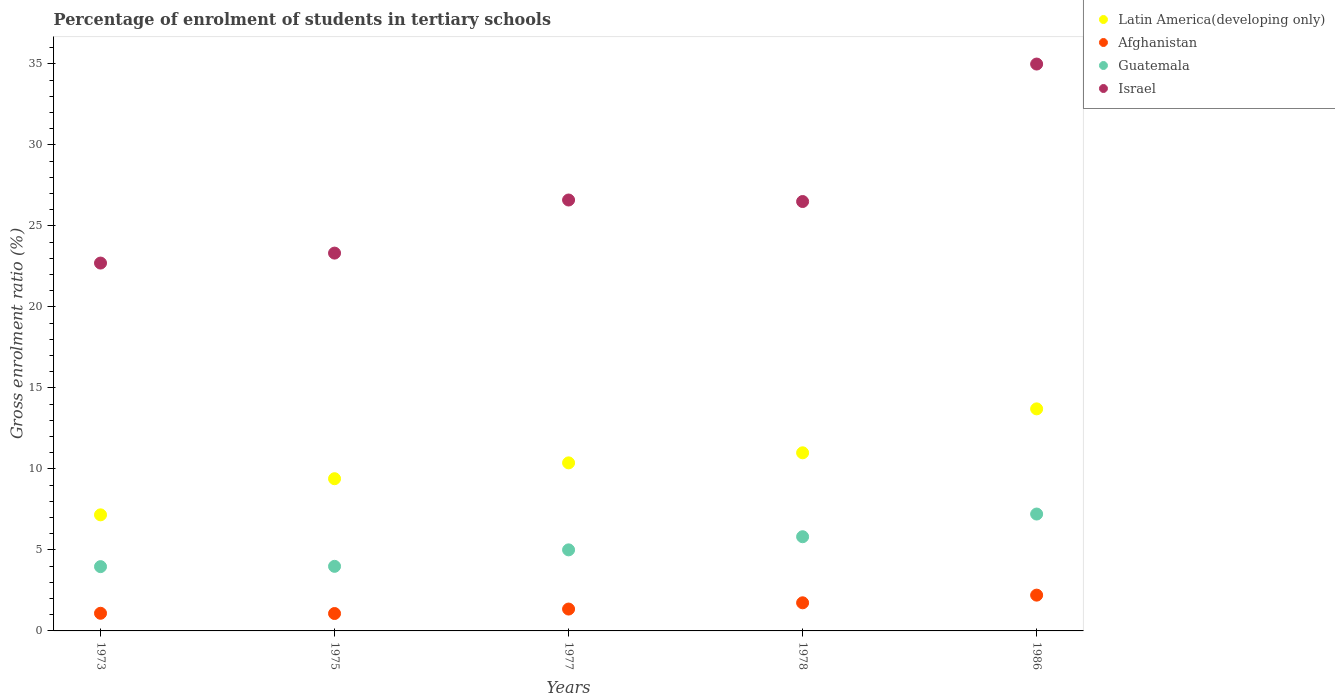Is the number of dotlines equal to the number of legend labels?
Your answer should be very brief. Yes. What is the percentage of students enrolled in tertiary schools in Israel in 1973?
Provide a succinct answer. 22.71. Across all years, what is the maximum percentage of students enrolled in tertiary schools in Guatemala?
Your answer should be compact. 7.21. Across all years, what is the minimum percentage of students enrolled in tertiary schools in Israel?
Your response must be concise. 22.71. In which year was the percentage of students enrolled in tertiary schools in Afghanistan minimum?
Your answer should be compact. 1975. What is the total percentage of students enrolled in tertiary schools in Latin America(developing only) in the graph?
Offer a very short reply. 51.63. What is the difference between the percentage of students enrolled in tertiary schools in Afghanistan in 1977 and that in 1986?
Your answer should be very brief. -0.86. What is the difference between the percentage of students enrolled in tertiary schools in Afghanistan in 1973 and the percentage of students enrolled in tertiary schools in Guatemala in 1977?
Your response must be concise. -3.91. What is the average percentage of students enrolled in tertiary schools in Latin America(developing only) per year?
Provide a short and direct response. 10.33. In the year 1975, what is the difference between the percentage of students enrolled in tertiary schools in Israel and percentage of students enrolled in tertiary schools in Afghanistan?
Offer a terse response. 22.25. In how many years, is the percentage of students enrolled in tertiary schools in Latin America(developing only) greater than 18 %?
Your answer should be very brief. 0. What is the ratio of the percentage of students enrolled in tertiary schools in Guatemala in 1975 to that in 1978?
Offer a very short reply. 0.69. What is the difference between the highest and the second highest percentage of students enrolled in tertiary schools in Latin America(developing only)?
Offer a terse response. 2.71. What is the difference between the highest and the lowest percentage of students enrolled in tertiary schools in Israel?
Offer a very short reply. 12.28. In how many years, is the percentage of students enrolled in tertiary schools in Afghanistan greater than the average percentage of students enrolled in tertiary schools in Afghanistan taken over all years?
Make the answer very short. 2. Is the sum of the percentage of students enrolled in tertiary schools in Guatemala in 1977 and 1986 greater than the maximum percentage of students enrolled in tertiary schools in Afghanistan across all years?
Give a very brief answer. Yes. Is it the case that in every year, the sum of the percentage of students enrolled in tertiary schools in Latin America(developing only) and percentage of students enrolled in tertiary schools in Israel  is greater than the sum of percentage of students enrolled in tertiary schools in Afghanistan and percentage of students enrolled in tertiary schools in Guatemala?
Provide a succinct answer. Yes. Is it the case that in every year, the sum of the percentage of students enrolled in tertiary schools in Latin America(developing only) and percentage of students enrolled in tertiary schools in Guatemala  is greater than the percentage of students enrolled in tertiary schools in Israel?
Offer a very short reply. No. Does the percentage of students enrolled in tertiary schools in Guatemala monotonically increase over the years?
Your answer should be very brief. Yes. Is the percentage of students enrolled in tertiary schools in Latin America(developing only) strictly greater than the percentage of students enrolled in tertiary schools in Guatemala over the years?
Your response must be concise. Yes. Is the percentage of students enrolled in tertiary schools in Afghanistan strictly less than the percentage of students enrolled in tertiary schools in Guatemala over the years?
Ensure brevity in your answer.  Yes. How many years are there in the graph?
Your answer should be very brief. 5. Are the values on the major ticks of Y-axis written in scientific E-notation?
Your answer should be very brief. No. Does the graph contain grids?
Your answer should be very brief. No. Where does the legend appear in the graph?
Offer a terse response. Top right. What is the title of the graph?
Your response must be concise. Percentage of enrolment of students in tertiary schools. What is the Gross enrolment ratio (%) of Latin America(developing only) in 1973?
Offer a terse response. 7.16. What is the Gross enrolment ratio (%) in Afghanistan in 1973?
Your answer should be compact. 1.09. What is the Gross enrolment ratio (%) in Guatemala in 1973?
Keep it short and to the point. 3.97. What is the Gross enrolment ratio (%) in Israel in 1973?
Keep it short and to the point. 22.71. What is the Gross enrolment ratio (%) of Latin America(developing only) in 1975?
Give a very brief answer. 9.4. What is the Gross enrolment ratio (%) of Afghanistan in 1975?
Ensure brevity in your answer.  1.07. What is the Gross enrolment ratio (%) in Guatemala in 1975?
Provide a short and direct response. 3.99. What is the Gross enrolment ratio (%) in Israel in 1975?
Your answer should be compact. 23.32. What is the Gross enrolment ratio (%) of Latin America(developing only) in 1977?
Provide a succinct answer. 10.37. What is the Gross enrolment ratio (%) in Afghanistan in 1977?
Give a very brief answer. 1.35. What is the Gross enrolment ratio (%) in Guatemala in 1977?
Offer a terse response. 5. What is the Gross enrolment ratio (%) of Israel in 1977?
Provide a succinct answer. 26.6. What is the Gross enrolment ratio (%) of Latin America(developing only) in 1978?
Your response must be concise. 10.99. What is the Gross enrolment ratio (%) of Afghanistan in 1978?
Keep it short and to the point. 1.74. What is the Gross enrolment ratio (%) of Guatemala in 1978?
Your answer should be compact. 5.81. What is the Gross enrolment ratio (%) of Israel in 1978?
Your answer should be compact. 26.5. What is the Gross enrolment ratio (%) in Latin America(developing only) in 1986?
Ensure brevity in your answer.  13.71. What is the Gross enrolment ratio (%) of Afghanistan in 1986?
Your answer should be compact. 2.21. What is the Gross enrolment ratio (%) in Guatemala in 1986?
Make the answer very short. 7.21. What is the Gross enrolment ratio (%) in Israel in 1986?
Keep it short and to the point. 34.99. Across all years, what is the maximum Gross enrolment ratio (%) of Latin America(developing only)?
Offer a terse response. 13.71. Across all years, what is the maximum Gross enrolment ratio (%) in Afghanistan?
Provide a succinct answer. 2.21. Across all years, what is the maximum Gross enrolment ratio (%) of Guatemala?
Provide a succinct answer. 7.21. Across all years, what is the maximum Gross enrolment ratio (%) of Israel?
Keep it short and to the point. 34.99. Across all years, what is the minimum Gross enrolment ratio (%) of Latin America(developing only)?
Provide a succinct answer. 7.16. Across all years, what is the minimum Gross enrolment ratio (%) in Afghanistan?
Your response must be concise. 1.07. Across all years, what is the minimum Gross enrolment ratio (%) of Guatemala?
Your response must be concise. 3.97. Across all years, what is the minimum Gross enrolment ratio (%) in Israel?
Keep it short and to the point. 22.71. What is the total Gross enrolment ratio (%) in Latin America(developing only) in the graph?
Provide a succinct answer. 51.63. What is the total Gross enrolment ratio (%) of Afghanistan in the graph?
Offer a very short reply. 7.46. What is the total Gross enrolment ratio (%) in Guatemala in the graph?
Give a very brief answer. 25.99. What is the total Gross enrolment ratio (%) in Israel in the graph?
Offer a very short reply. 134.12. What is the difference between the Gross enrolment ratio (%) of Latin America(developing only) in 1973 and that in 1975?
Your answer should be very brief. -2.23. What is the difference between the Gross enrolment ratio (%) of Afghanistan in 1973 and that in 1975?
Make the answer very short. 0.02. What is the difference between the Gross enrolment ratio (%) in Guatemala in 1973 and that in 1975?
Make the answer very short. -0.02. What is the difference between the Gross enrolment ratio (%) of Israel in 1973 and that in 1975?
Offer a terse response. -0.61. What is the difference between the Gross enrolment ratio (%) of Latin America(developing only) in 1973 and that in 1977?
Make the answer very short. -3.21. What is the difference between the Gross enrolment ratio (%) of Afghanistan in 1973 and that in 1977?
Offer a very short reply. -0.26. What is the difference between the Gross enrolment ratio (%) of Guatemala in 1973 and that in 1977?
Give a very brief answer. -1.04. What is the difference between the Gross enrolment ratio (%) in Israel in 1973 and that in 1977?
Ensure brevity in your answer.  -3.89. What is the difference between the Gross enrolment ratio (%) of Latin America(developing only) in 1973 and that in 1978?
Give a very brief answer. -3.83. What is the difference between the Gross enrolment ratio (%) in Afghanistan in 1973 and that in 1978?
Provide a short and direct response. -0.65. What is the difference between the Gross enrolment ratio (%) in Guatemala in 1973 and that in 1978?
Your answer should be very brief. -1.85. What is the difference between the Gross enrolment ratio (%) of Israel in 1973 and that in 1978?
Your answer should be compact. -3.8. What is the difference between the Gross enrolment ratio (%) in Latin America(developing only) in 1973 and that in 1986?
Keep it short and to the point. -6.54. What is the difference between the Gross enrolment ratio (%) of Afghanistan in 1973 and that in 1986?
Your response must be concise. -1.12. What is the difference between the Gross enrolment ratio (%) of Guatemala in 1973 and that in 1986?
Ensure brevity in your answer.  -3.25. What is the difference between the Gross enrolment ratio (%) of Israel in 1973 and that in 1986?
Your answer should be compact. -12.28. What is the difference between the Gross enrolment ratio (%) of Latin America(developing only) in 1975 and that in 1977?
Your answer should be very brief. -0.98. What is the difference between the Gross enrolment ratio (%) of Afghanistan in 1975 and that in 1977?
Your answer should be compact. -0.28. What is the difference between the Gross enrolment ratio (%) of Guatemala in 1975 and that in 1977?
Provide a short and direct response. -1.02. What is the difference between the Gross enrolment ratio (%) of Israel in 1975 and that in 1977?
Ensure brevity in your answer.  -3.28. What is the difference between the Gross enrolment ratio (%) of Latin America(developing only) in 1975 and that in 1978?
Make the answer very short. -1.6. What is the difference between the Gross enrolment ratio (%) of Afghanistan in 1975 and that in 1978?
Offer a terse response. -0.66. What is the difference between the Gross enrolment ratio (%) in Guatemala in 1975 and that in 1978?
Give a very brief answer. -1.83. What is the difference between the Gross enrolment ratio (%) in Israel in 1975 and that in 1978?
Your response must be concise. -3.18. What is the difference between the Gross enrolment ratio (%) in Latin America(developing only) in 1975 and that in 1986?
Offer a terse response. -4.31. What is the difference between the Gross enrolment ratio (%) of Afghanistan in 1975 and that in 1986?
Offer a very short reply. -1.13. What is the difference between the Gross enrolment ratio (%) in Guatemala in 1975 and that in 1986?
Your answer should be compact. -3.23. What is the difference between the Gross enrolment ratio (%) in Israel in 1975 and that in 1986?
Your answer should be very brief. -11.67. What is the difference between the Gross enrolment ratio (%) of Latin America(developing only) in 1977 and that in 1978?
Provide a succinct answer. -0.62. What is the difference between the Gross enrolment ratio (%) of Afghanistan in 1977 and that in 1978?
Your answer should be very brief. -0.39. What is the difference between the Gross enrolment ratio (%) of Guatemala in 1977 and that in 1978?
Provide a succinct answer. -0.81. What is the difference between the Gross enrolment ratio (%) of Israel in 1977 and that in 1978?
Your response must be concise. 0.09. What is the difference between the Gross enrolment ratio (%) of Latin America(developing only) in 1977 and that in 1986?
Your response must be concise. -3.33. What is the difference between the Gross enrolment ratio (%) of Afghanistan in 1977 and that in 1986?
Ensure brevity in your answer.  -0.86. What is the difference between the Gross enrolment ratio (%) of Guatemala in 1977 and that in 1986?
Your response must be concise. -2.21. What is the difference between the Gross enrolment ratio (%) in Israel in 1977 and that in 1986?
Provide a short and direct response. -8.39. What is the difference between the Gross enrolment ratio (%) in Latin America(developing only) in 1978 and that in 1986?
Give a very brief answer. -2.71. What is the difference between the Gross enrolment ratio (%) in Afghanistan in 1978 and that in 1986?
Provide a succinct answer. -0.47. What is the difference between the Gross enrolment ratio (%) in Guatemala in 1978 and that in 1986?
Make the answer very short. -1.4. What is the difference between the Gross enrolment ratio (%) of Israel in 1978 and that in 1986?
Make the answer very short. -8.49. What is the difference between the Gross enrolment ratio (%) of Latin America(developing only) in 1973 and the Gross enrolment ratio (%) of Afghanistan in 1975?
Provide a succinct answer. 6.09. What is the difference between the Gross enrolment ratio (%) of Latin America(developing only) in 1973 and the Gross enrolment ratio (%) of Guatemala in 1975?
Keep it short and to the point. 3.18. What is the difference between the Gross enrolment ratio (%) in Latin America(developing only) in 1973 and the Gross enrolment ratio (%) in Israel in 1975?
Ensure brevity in your answer.  -16.16. What is the difference between the Gross enrolment ratio (%) in Afghanistan in 1973 and the Gross enrolment ratio (%) in Guatemala in 1975?
Your answer should be very brief. -2.9. What is the difference between the Gross enrolment ratio (%) in Afghanistan in 1973 and the Gross enrolment ratio (%) in Israel in 1975?
Your answer should be compact. -22.23. What is the difference between the Gross enrolment ratio (%) of Guatemala in 1973 and the Gross enrolment ratio (%) of Israel in 1975?
Provide a short and direct response. -19.35. What is the difference between the Gross enrolment ratio (%) of Latin America(developing only) in 1973 and the Gross enrolment ratio (%) of Afghanistan in 1977?
Your answer should be compact. 5.81. What is the difference between the Gross enrolment ratio (%) of Latin America(developing only) in 1973 and the Gross enrolment ratio (%) of Guatemala in 1977?
Offer a very short reply. 2.16. What is the difference between the Gross enrolment ratio (%) in Latin America(developing only) in 1973 and the Gross enrolment ratio (%) in Israel in 1977?
Keep it short and to the point. -19.43. What is the difference between the Gross enrolment ratio (%) in Afghanistan in 1973 and the Gross enrolment ratio (%) in Guatemala in 1977?
Your answer should be compact. -3.91. What is the difference between the Gross enrolment ratio (%) of Afghanistan in 1973 and the Gross enrolment ratio (%) of Israel in 1977?
Offer a very short reply. -25.51. What is the difference between the Gross enrolment ratio (%) in Guatemala in 1973 and the Gross enrolment ratio (%) in Israel in 1977?
Make the answer very short. -22.63. What is the difference between the Gross enrolment ratio (%) of Latin America(developing only) in 1973 and the Gross enrolment ratio (%) of Afghanistan in 1978?
Ensure brevity in your answer.  5.43. What is the difference between the Gross enrolment ratio (%) of Latin America(developing only) in 1973 and the Gross enrolment ratio (%) of Guatemala in 1978?
Provide a short and direct response. 1.35. What is the difference between the Gross enrolment ratio (%) in Latin America(developing only) in 1973 and the Gross enrolment ratio (%) in Israel in 1978?
Your answer should be compact. -19.34. What is the difference between the Gross enrolment ratio (%) in Afghanistan in 1973 and the Gross enrolment ratio (%) in Guatemala in 1978?
Make the answer very short. -4.72. What is the difference between the Gross enrolment ratio (%) in Afghanistan in 1973 and the Gross enrolment ratio (%) in Israel in 1978?
Provide a short and direct response. -25.41. What is the difference between the Gross enrolment ratio (%) in Guatemala in 1973 and the Gross enrolment ratio (%) in Israel in 1978?
Your answer should be very brief. -22.54. What is the difference between the Gross enrolment ratio (%) of Latin America(developing only) in 1973 and the Gross enrolment ratio (%) of Afghanistan in 1986?
Provide a short and direct response. 4.96. What is the difference between the Gross enrolment ratio (%) in Latin America(developing only) in 1973 and the Gross enrolment ratio (%) in Guatemala in 1986?
Make the answer very short. -0.05. What is the difference between the Gross enrolment ratio (%) in Latin America(developing only) in 1973 and the Gross enrolment ratio (%) in Israel in 1986?
Offer a terse response. -27.82. What is the difference between the Gross enrolment ratio (%) of Afghanistan in 1973 and the Gross enrolment ratio (%) of Guatemala in 1986?
Your answer should be very brief. -6.12. What is the difference between the Gross enrolment ratio (%) in Afghanistan in 1973 and the Gross enrolment ratio (%) in Israel in 1986?
Keep it short and to the point. -33.9. What is the difference between the Gross enrolment ratio (%) of Guatemala in 1973 and the Gross enrolment ratio (%) of Israel in 1986?
Ensure brevity in your answer.  -31.02. What is the difference between the Gross enrolment ratio (%) of Latin America(developing only) in 1975 and the Gross enrolment ratio (%) of Afghanistan in 1977?
Your answer should be very brief. 8.05. What is the difference between the Gross enrolment ratio (%) in Latin America(developing only) in 1975 and the Gross enrolment ratio (%) in Guatemala in 1977?
Your answer should be very brief. 4.39. What is the difference between the Gross enrolment ratio (%) in Latin America(developing only) in 1975 and the Gross enrolment ratio (%) in Israel in 1977?
Provide a short and direct response. -17.2. What is the difference between the Gross enrolment ratio (%) of Afghanistan in 1975 and the Gross enrolment ratio (%) of Guatemala in 1977?
Offer a very short reply. -3.93. What is the difference between the Gross enrolment ratio (%) in Afghanistan in 1975 and the Gross enrolment ratio (%) in Israel in 1977?
Your answer should be compact. -25.52. What is the difference between the Gross enrolment ratio (%) in Guatemala in 1975 and the Gross enrolment ratio (%) in Israel in 1977?
Your response must be concise. -22.61. What is the difference between the Gross enrolment ratio (%) of Latin America(developing only) in 1975 and the Gross enrolment ratio (%) of Afghanistan in 1978?
Provide a succinct answer. 7.66. What is the difference between the Gross enrolment ratio (%) in Latin America(developing only) in 1975 and the Gross enrolment ratio (%) in Guatemala in 1978?
Make the answer very short. 3.58. What is the difference between the Gross enrolment ratio (%) in Latin America(developing only) in 1975 and the Gross enrolment ratio (%) in Israel in 1978?
Provide a succinct answer. -17.11. What is the difference between the Gross enrolment ratio (%) in Afghanistan in 1975 and the Gross enrolment ratio (%) in Guatemala in 1978?
Provide a short and direct response. -4.74. What is the difference between the Gross enrolment ratio (%) of Afghanistan in 1975 and the Gross enrolment ratio (%) of Israel in 1978?
Offer a terse response. -25.43. What is the difference between the Gross enrolment ratio (%) in Guatemala in 1975 and the Gross enrolment ratio (%) in Israel in 1978?
Keep it short and to the point. -22.52. What is the difference between the Gross enrolment ratio (%) of Latin America(developing only) in 1975 and the Gross enrolment ratio (%) of Afghanistan in 1986?
Ensure brevity in your answer.  7.19. What is the difference between the Gross enrolment ratio (%) in Latin America(developing only) in 1975 and the Gross enrolment ratio (%) in Guatemala in 1986?
Provide a short and direct response. 2.18. What is the difference between the Gross enrolment ratio (%) of Latin America(developing only) in 1975 and the Gross enrolment ratio (%) of Israel in 1986?
Keep it short and to the point. -25.59. What is the difference between the Gross enrolment ratio (%) of Afghanistan in 1975 and the Gross enrolment ratio (%) of Guatemala in 1986?
Your answer should be compact. -6.14. What is the difference between the Gross enrolment ratio (%) in Afghanistan in 1975 and the Gross enrolment ratio (%) in Israel in 1986?
Your response must be concise. -33.91. What is the difference between the Gross enrolment ratio (%) of Guatemala in 1975 and the Gross enrolment ratio (%) of Israel in 1986?
Offer a terse response. -31. What is the difference between the Gross enrolment ratio (%) of Latin America(developing only) in 1977 and the Gross enrolment ratio (%) of Afghanistan in 1978?
Your response must be concise. 8.64. What is the difference between the Gross enrolment ratio (%) in Latin America(developing only) in 1977 and the Gross enrolment ratio (%) in Guatemala in 1978?
Your answer should be compact. 4.56. What is the difference between the Gross enrolment ratio (%) in Latin America(developing only) in 1977 and the Gross enrolment ratio (%) in Israel in 1978?
Offer a terse response. -16.13. What is the difference between the Gross enrolment ratio (%) in Afghanistan in 1977 and the Gross enrolment ratio (%) in Guatemala in 1978?
Offer a very short reply. -4.46. What is the difference between the Gross enrolment ratio (%) in Afghanistan in 1977 and the Gross enrolment ratio (%) in Israel in 1978?
Your answer should be compact. -25.15. What is the difference between the Gross enrolment ratio (%) of Guatemala in 1977 and the Gross enrolment ratio (%) of Israel in 1978?
Give a very brief answer. -21.5. What is the difference between the Gross enrolment ratio (%) in Latin America(developing only) in 1977 and the Gross enrolment ratio (%) in Afghanistan in 1986?
Provide a short and direct response. 8.16. What is the difference between the Gross enrolment ratio (%) in Latin America(developing only) in 1977 and the Gross enrolment ratio (%) in Guatemala in 1986?
Your answer should be very brief. 3.16. What is the difference between the Gross enrolment ratio (%) of Latin America(developing only) in 1977 and the Gross enrolment ratio (%) of Israel in 1986?
Offer a terse response. -24.62. What is the difference between the Gross enrolment ratio (%) of Afghanistan in 1977 and the Gross enrolment ratio (%) of Guatemala in 1986?
Offer a terse response. -5.86. What is the difference between the Gross enrolment ratio (%) in Afghanistan in 1977 and the Gross enrolment ratio (%) in Israel in 1986?
Offer a very short reply. -33.64. What is the difference between the Gross enrolment ratio (%) of Guatemala in 1977 and the Gross enrolment ratio (%) of Israel in 1986?
Offer a terse response. -29.99. What is the difference between the Gross enrolment ratio (%) of Latin America(developing only) in 1978 and the Gross enrolment ratio (%) of Afghanistan in 1986?
Keep it short and to the point. 8.79. What is the difference between the Gross enrolment ratio (%) in Latin America(developing only) in 1978 and the Gross enrolment ratio (%) in Guatemala in 1986?
Your answer should be very brief. 3.78. What is the difference between the Gross enrolment ratio (%) in Latin America(developing only) in 1978 and the Gross enrolment ratio (%) in Israel in 1986?
Make the answer very short. -24. What is the difference between the Gross enrolment ratio (%) in Afghanistan in 1978 and the Gross enrolment ratio (%) in Guatemala in 1986?
Your answer should be compact. -5.48. What is the difference between the Gross enrolment ratio (%) of Afghanistan in 1978 and the Gross enrolment ratio (%) of Israel in 1986?
Provide a succinct answer. -33.25. What is the difference between the Gross enrolment ratio (%) in Guatemala in 1978 and the Gross enrolment ratio (%) in Israel in 1986?
Ensure brevity in your answer.  -29.18. What is the average Gross enrolment ratio (%) in Latin America(developing only) per year?
Give a very brief answer. 10.33. What is the average Gross enrolment ratio (%) of Afghanistan per year?
Your answer should be very brief. 1.49. What is the average Gross enrolment ratio (%) in Guatemala per year?
Your answer should be compact. 5.2. What is the average Gross enrolment ratio (%) of Israel per year?
Your response must be concise. 26.82. In the year 1973, what is the difference between the Gross enrolment ratio (%) of Latin America(developing only) and Gross enrolment ratio (%) of Afghanistan?
Offer a very short reply. 6.08. In the year 1973, what is the difference between the Gross enrolment ratio (%) of Latin America(developing only) and Gross enrolment ratio (%) of Guatemala?
Keep it short and to the point. 3.2. In the year 1973, what is the difference between the Gross enrolment ratio (%) in Latin America(developing only) and Gross enrolment ratio (%) in Israel?
Ensure brevity in your answer.  -15.54. In the year 1973, what is the difference between the Gross enrolment ratio (%) in Afghanistan and Gross enrolment ratio (%) in Guatemala?
Your answer should be very brief. -2.88. In the year 1973, what is the difference between the Gross enrolment ratio (%) of Afghanistan and Gross enrolment ratio (%) of Israel?
Your response must be concise. -21.62. In the year 1973, what is the difference between the Gross enrolment ratio (%) of Guatemala and Gross enrolment ratio (%) of Israel?
Ensure brevity in your answer.  -18.74. In the year 1975, what is the difference between the Gross enrolment ratio (%) of Latin America(developing only) and Gross enrolment ratio (%) of Afghanistan?
Your response must be concise. 8.32. In the year 1975, what is the difference between the Gross enrolment ratio (%) in Latin America(developing only) and Gross enrolment ratio (%) in Guatemala?
Make the answer very short. 5.41. In the year 1975, what is the difference between the Gross enrolment ratio (%) in Latin America(developing only) and Gross enrolment ratio (%) in Israel?
Your response must be concise. -13.92. In the year 1975, what is the difference between the Gross enrolment ratio (%) in Afghanistan and Gross enrolment ratio (%) in Guatemala?
Give a very brief answer. -2.91. In the year 1975, what is the difference between the Gross enrolment ratio (%) of Afghanistan and Gross enrolment ratio (%) of Israel?
Give a very brief answer. -22.25. In the year 1975, what is the difference between the Gross enrolment ratio (%) in Guatemala and Gross enrolment ratio (%) in Israel?
Offer a very short reply. -19.33. In the year 1977, what is the difference between the Gross enrolment ratio (%) of Latin America(developing only) and Gross enrolment ratio (%) of Afghanistan?
Provide a short and direct response. 9.02. In the year 1977, what is the difference between the Gross enrolment ratio (%) of Latin America(developing only) and Gross enrolment ratio (%) of Guatemala?
Your response must be concise. 5.37. In the year 1977, what is the difference between the Gross enrolment ratio (%) in Latin America(developing only) and Gross enrolment ratio (%) in Israel?
Ensure brevity in your answer.  -16.22. In the year 1977, what is the difference between the Gross enrolment ratio (%) in Afghanistan and Gross enrolment ratio (%) in Guatemala?
Your answer should be very brief. -3.65. In the year 1977, what is the difference between the Gross enrolment ratio (%) of Afghanistan and Gross enrolment ratio (%) of Israel?
Your response must be concise. -25.25. In the year 1977, what is the difference between the Gross enrolment ratio (%) in Guatemala and Gross enrolment ratio (%) in Israel?
Your answer should be compact. -21.59. In the year 1978, what is the difference between the Gross enrolment ratio (%) in Latin America(developing only) and Gross enrolment ratio (%) in Afghanistan?
Offer a very short reply. 9.26. In the year 1978, what is the difference between the Gross enrolment ratio (%) in Latin America(developing only) and Gross enrolment ratio (%) in Guatemala?
Your response must be concise. 5.18. In the year 1978, what is the difference between the Gross enrolment ratio (%) in Latin America(developing only) and Gross enrolment ratio (%) in Israel?
Offer a very short reply. -15.51. In the year 1978, what is the difference between the Gross enrolment ratio (%) of Afghanistan and Gross enrolment ratio (%) of Guatemala?
Provide a succinct answer. -4.08. In the year 1978, what is the difference between the Gross enrolment ratio (%) of Afghanistan and Gross enrolment ratio (%) of Israel?
Offer a terse response. -24.77. In the year 1978, what is the difference between the Gross enrolment ratio (%) of Guatemala and Gross enrolment ratio (%) of Israel?
Provide a succinct answer. -20.69. In the year 1986, what is the difference between the Gross enrolment ratio (%) in Latin America(developing only) and Gross enrolment ratio (%) in Afghanistan?
Provide a short and direct response. 11.5. In the year 1986, what is the difference between the Gross enrolment ratio (%) in Latin America(developing only) and Gross enrolment ratio (%) in Guatemala?
Your answer should be compact. 6.49. In the year 1986, what is the difference between the Gross enrolment ratio (%) of Latin America(developing only) and Gross enrolment ratio (%) of Israel?
Your answer should be compact. -21.28. In the year 1986, what is the difference between the Gross enrolment ratio (%) of Afghanistan and Gross enrolment ratio (%) of Guatemala?
Provide a succinct answer. -5.01. In the year 1986, what is the difference between the Gross enrolment ratio (%) of Afghanistan and Gross enrolment ratio (%) of Israel?
Offer a very short reply. -32.78. In the year 1986, what is the difference between the Gross enrolment ratio (%) in Guatemala and Gross enrolment ratio (%) in Israel?
Your answer should be compact. -27.77. What is the ratio of the Gross enrolment ratio (%) of Latin America(developing only) in 1973 to that in 1975?
Offer a terse response. 0.76. What is the ratio of the Gross enrolment ratio (%) in Afghanistan in 1973 to that in 1975?
Ensure brevity in your answer.  1.01. What is the ratio of the Gross enrolment ratio (%) in Guatemala in 1973 to that in 1975?
Your answer should be very brief. 1. What is the ratio of the Gross enrolment ratio (%) of Israel in 1973 to that in 1975?
Your answer should be very brief. 0.97. What is the ratio of the Gross enrolment ratio (%) in Latin America(developing only) in 1973 to that in 1977?
Keep it short and to the point. 0.69. What is the ratio of the Gross enrolment ratio (%) of Afghanistan in 1973 to that in 1977?
Ensure brevity in your answer.  0.81. What is the ratio of the Gross enrolment ratio (%) in Guatemala in 1973 to that in 1977?
Ensure brevity in your answer.  0.79. What is the ratio of the Gross enrolment ratio (%) of Israel in 1973 to that in 1977?
Make the answer very short. 0.85. What is the ratio of the Gross enrolment ratio (%) of Latin America(developing only) in 1973 to that in 1978?
Give a very brief answer. 0.65. What is the ratio of the Gross enrolment ratio (%) of Afghanistan in 1973 to that in 1978?
Keep it short and to the point. 0.63. What is the ratio of the Gross enrolment ratio (%) of Guatemala in 1973 to that in 1978?
Provide a short and direct response. 0.68. What is the ratio of the Gross enrolment ratio (%) in Israel in 1973 to that in 1978?
Provide a short and direct response. 0.86. What is the ratio of the Gross enrolment ratio (%) in Latin America(developing only) in 1973 to that in 1986?
Make the answer very short. 0.52. What is the ratio of the Gross enrolment ratio (%) of Afghanistan in 1973 to that in 1986?
Give a very brief answer. 0.49. What is the ratio of the Gross enrolment ratio (%) in Guatemala in 1973 to that in 1986?
Your answer should be very brief. 0.55. What is the ratio of the Gross enrolment ratio (%) of Israel in 1973 to that in 1986?
Make the answer very short. 0.65. What is the ratio of the Gross enrolment ratio (%) in Latin America(developing only) in 1975 to that in 1977?
Your answer should be very brief. 0.91. What is the ratio of the Gross enrolment ratio (%) in Afghanistan in 1975 to that in 1977?
Your answer should be very brief. 0.8. What is the ratio of the Gross enrolment ratio (%) in Guatemala in 1975 to that in 1977?
Keep it short and to the point. 0.8. What is the ratio of the Gross enrolment ratio (%) in Israel in 1975 to that in 1977?
Ensure brevity in your answer.  0.88. What is the ratio of the Gross enrolment ratio (%) of Latin America(developing only) in 1975 to that in 1978?
Offer a very short reply. 0.85. What is the ratio of the Gross enrolment ratio (%) of Afghanistan in 1975 to that in 1978?
Give a very brief answer. 0.62. What is the ratio of the Gross enrolment ratio (%) of Guatemala in 1975 to that in 1978?
Offer a terse response. 0.69. What is the ratio of the Gross enrolment ratio (%) of Israel in 1975 to that in 1978?
Give a very brief answer. 0.88. What is the ratio of the Gross enrolment ratio (%) in Latin America(developing only) in 1975 to that in 1986?
Provide a short and direct response. 0.69. What is the ratio of the Gross enrolment ratio (%) of Afghanistan in 1975 to that in 1986?
Ensure brevity in your answer.  0.49. What is the ratio of the Gross enrolment ratio (%) of Guatemala in 1975 to that in 1986?
Make the answer very short. 0.55. What is the ratio of the Gross enrolment ratio (%) of Israel in 1975 to that in 1986?
Make the answer very short. 0.67. What is the ratio of the Gross enrolment ratio (%) of Latin America(developing only) in 1977 to that in 1978?
Offer a terse response. 0.94. What is the ratio of the Gross enrolment ratio (%) in Afghanistan in 1977 to that in 1978?
Offer a terse response. 0.78. What is the ratio of the Gross enrolment ratio (%) of Guatemala in 1977 to that in 1978?
Your response must be concise. 0.86. What is the ratio of the Gross enrolment ratio (%) in Israel in 1977 to that in 1978?
Keep it short and to the point. 1. What is the ratio of the Gross enrolment ratio (%) of Latin America(developing only) in 1977 to that in 1986?
Your response must be concise. 0.76. What is the ratio of the Gross enrolment ratio (%) of Afghanistan in 1977 to that in 1986?
Give a very brief answer. 0.61. What is the ratio of the Gross enrolment ratio (%) of Guatemala in 1977 to that in 1986?
Ensure brevity in your answer.  0.69. What is the ratio of the Gross enrolment ratio (%) in Israel in 1977 to that in 1986?
Your answer should be very brief. 0.76. What is the ratio of the Gross enrolment ratio (%) of Latin America(developing only) in 1978 to that in 1986?
Your answer should be very brief. 0.8. What is the ratio of the Gross enrolment ratio (%) in Afghanistan in 1978 to that in 1986?
Offer a terse response. 0.79. What is the ratio of the Gross enrolment ratio (%) in Guatemala in 1978 to that in 1986?
Keep it short and to the point. 0.81. What is the ratio of the Gross enrolment ratio (%) of Israel in 1978 to that in 1986?
Offer a terse response. 0.76. What is the difference between the highest and the second highest Gross enrolment ratio (%) in Latin America(developing only)?
Give a very brief answer. 2.71. What is the difference between the highest and the second highest Gross enrolment ratio (%) in Afghanistan?
Make the answer very short. 0.47. What is the difference between the highest and the second highest Gross enrolment ratio (%) of Guatemala?
Keep it short and to the point. 1.4. What is the difference between the highest and the second highest Gross enrolment ratio (%) of Israel?
Provide a succinct answer. 8.39. What is the difference between the highest and the lowest Gross enrolment ratio (%) of Latin America(developing only)?
Provide a short and direct response. 6.54. What is the difference between the highest and the lowest Gross enrolment ratio (%) in Afghanistan?
Ensure brevity in your answer.  1.13. What is the difference between the highest and the lowest Gross enrolment ratio (%) of Guatemala?
Offer a terse response. 3.25. What is the difference between the highest and the lowest Gross enrolment ratio (%) in Israel?
Offer a very short reply. 12.28. 